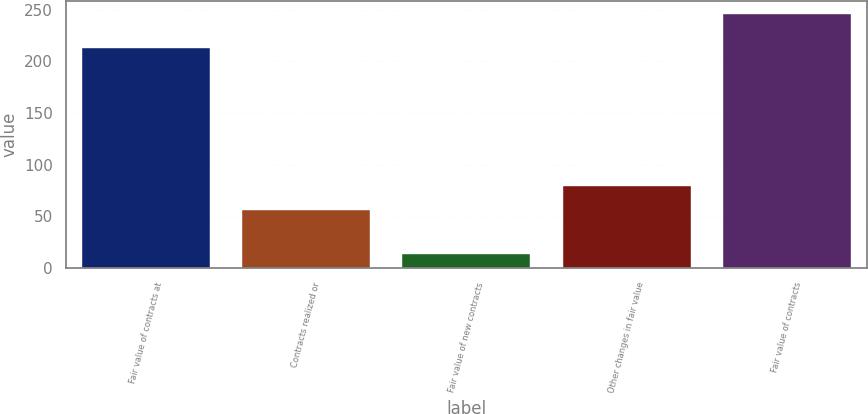Convert chart. <chart><loc_0><loc_0><loc_500><loc_500><bar_chart><fcel>Fair value of contracts at<fcel>Contracts realized or<fcel>Fair value of new contracts<fcel>Other changes in fair value<fcel>Fair value of contracts<nl><fcel>213<fcel>56<fcel>13<fcel>79.3<fcel>246<nl></chart> 